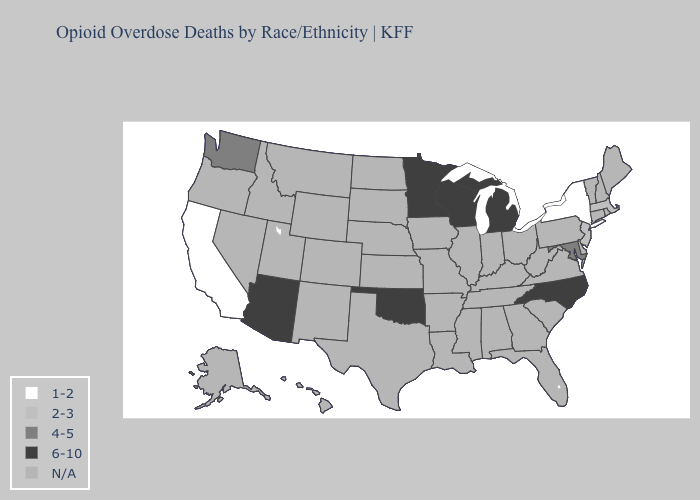Name the states that have a value in the range 6-10?
Write a very short answer. Arizona, Michigan, Minnesota, North Carolina, Oklahoma, Wisconsin. What is the value of South Dakota?
Keep it brief. N/A. What is the highest value in states that border New Jersey?
Keep it brief. 1-2. How many symbols are there in the legend?
Short answer required. 5. Name the states that have a value in the range 2-3?
Quick response, please. Massachusetts, New Jersey. How many symbols are there in the legend?
Give a very brief answer. 5. Name the states that have a value in the range 6-10?
Answer briefly. Arizona, Michigan, Minnesota, North Carolina, Oklahoma, Wisconsin. What is the value of California?
Answer briefly. 1-2. Name the states that have a value in the range 6-10?
Quick response, please. Arizona, Michigan, Minnesota, North Carolina, Oklahoma, Wisconsin. Which states have the highest value in the USA?
Write a very short answer. Arizona, Michigan, Minnesota, North Carolina, Oklahoma, Wisconsin. Is the legend a continuous bar?
Be succinct. No. What is the value of Maryland?
Quick response, please. 4-5. Does the map have missing data?
Be succinct. Yes. 